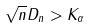<formula> <loc_0><loc_0><loc_500><loc_500>\sqrt { n } D _ { n } > K _ { \alpha }</formula> 